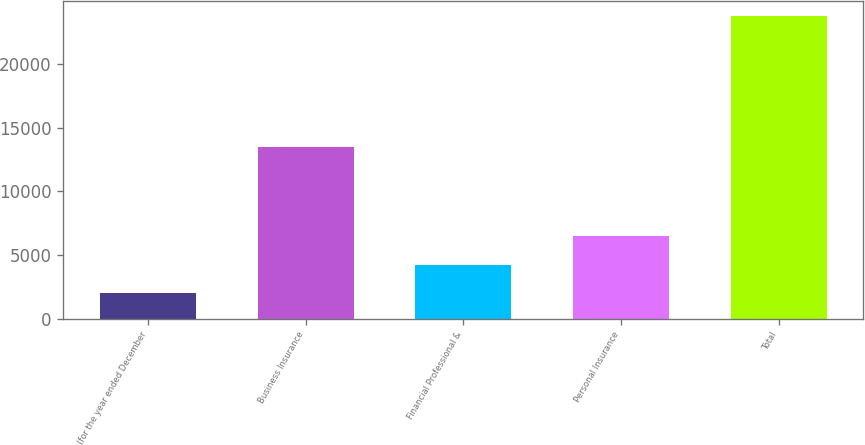Convert chart to OTSL. <chart><loc_0><loc_0><loc_500><loc_500><bar_chart><fcel>(for the year ended December<fcel>Business Insurance<fcel>Financial Professional &<fcel>Personal Insurance<fcel>Total<nl><fcel>2005<fcel>13453<fcel>4178.1<fcel>6474<fcel>23736<nl></chart> 